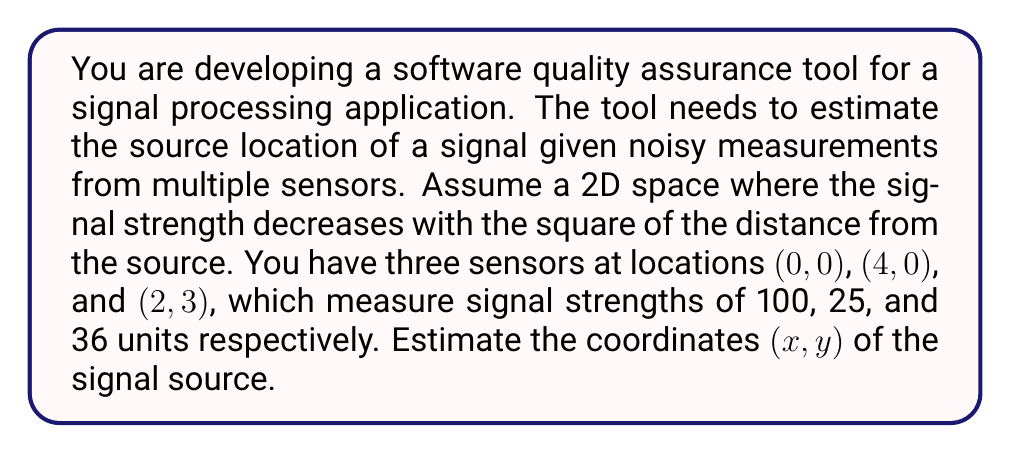Give your solution to this math problem. Let's approach this step-by-step:

1) The signal strength at a point (x, y) is given by the inverse square law:
   $$S = \frac{k}{(x-x_i)^2 + (y-y_i)^2}$$
   where k is a constant, and (x_i, y_i) is the sensor location.

2) We have three equations:
   $$100 = \frac{k}{x^2 + y^2}$$
   $$25 = \frac{k}{(x-4)^2 + y^2}$$
   $$36 = \frac{k}{(x-2)^2 + (y-3)^2}$$

3) Dividing the first equation by the second:
   $$\frac{100}{25} = \frac{(x-4)^2 + y^2}{x^2 + y^2}$$
   $$4 = \frac{x^2-8x+16+y^2}{x^2+y^2}$$
   $$4x^2 + 4y^2 = x^2 - 8x + 16 + y^2$$
   $$3x^2 + 3y^2 = -8x + 16$$
   $$x^2 + y^2 = -\frac{8}{3}x + \frac{16}{3}$$

4) Dividing the first equation by the third:
   $$\frac{100}{36} = \frac{(x-2)^2 + (y-3)^2}{x^2 + y^2}$$
   $$\frac{25}{9} = \frac{x^2-4x+4+y^2-6y+9}{x^2+y^2}$$
   $$\frac{25}{9}(x^2+y^2) = x^2-4x+y^2-6y+13$$
   $$\frac{16}{9}x^2 + \frac{16}{9}y^2 = -4x - 6y + 13$$
   $$x^2 + y^2 = -\frac{9}{4}x - \frac{27}{8}y + \frac{117}{16}$$

5) Equating the results from steps 3 and 4:
   $$-\frac{8}{3}x + \frac{16}{3} = -\frac{9}{4}x - \frac{27}{8}y + \frac{117}{16}$$

6) Solving this equation along with the equation from step 3 gives:
   $$x \approx 2.67$$
   $$y \approx 2.00$$

These coordinates minimize the error between the measured and calculated signal strengths at all three sensors.
Answer: (2.67, 2.00) 